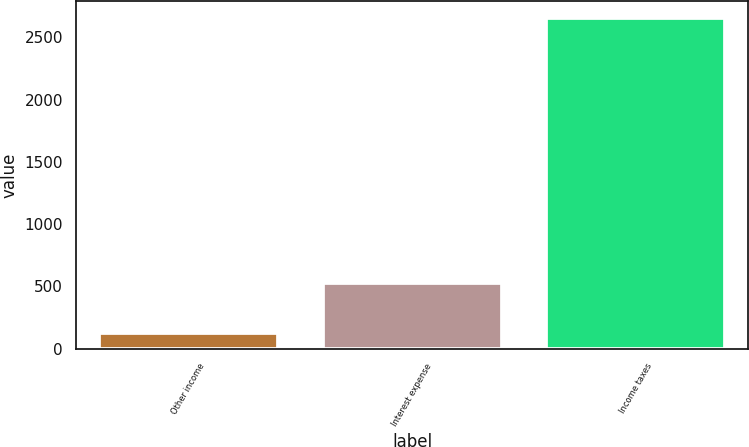<chart> <loc_0><loc_0><loc_500><loc_500><bar_chart><fcel>Other income<fcel>Interest expense<fcel>Income taxes<nl><fcel>128<fcel>526<fcel>2660<nl></chart> 